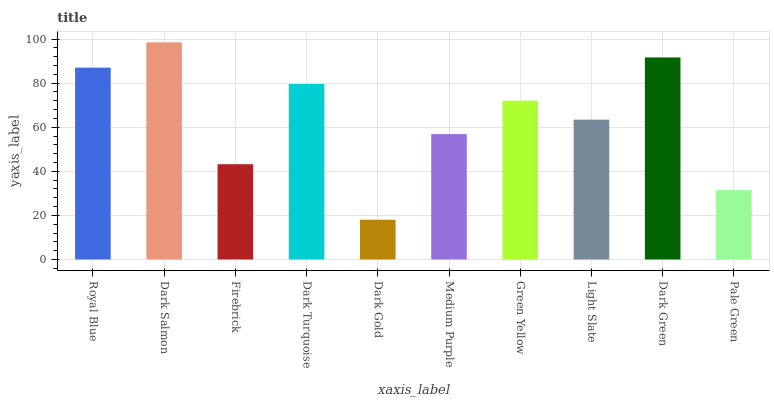Is Dark Gold the minimum?
Answer yes or no. Yes. Is Dark Salmon the maximum?
Answer yes or no. Yes. Is Firebrick the minimum?
Answer yes or no. No. Is Firebrick the maximum?
Answer yes or no. No. Is Dark Salmon greater than Firebrick?
Answer yes or no. Yes. Is Firebrick less than Dark Salmon?
Answer yes or no. Yes. Is Firebrick greater than Dark Salmon?
Answer yes or no. No. Is Dark Salmon less than Firebrick?
Answer yes or no. No. Is Green Yellow the high median?
Answer yes or no. Yes. Is Light Slate the low median?
Answer yes or no. Yes. Is Light Slate the high median?
Answer yes or no. No. Is Royal Blue the low median?
Answer yes or no. No. 